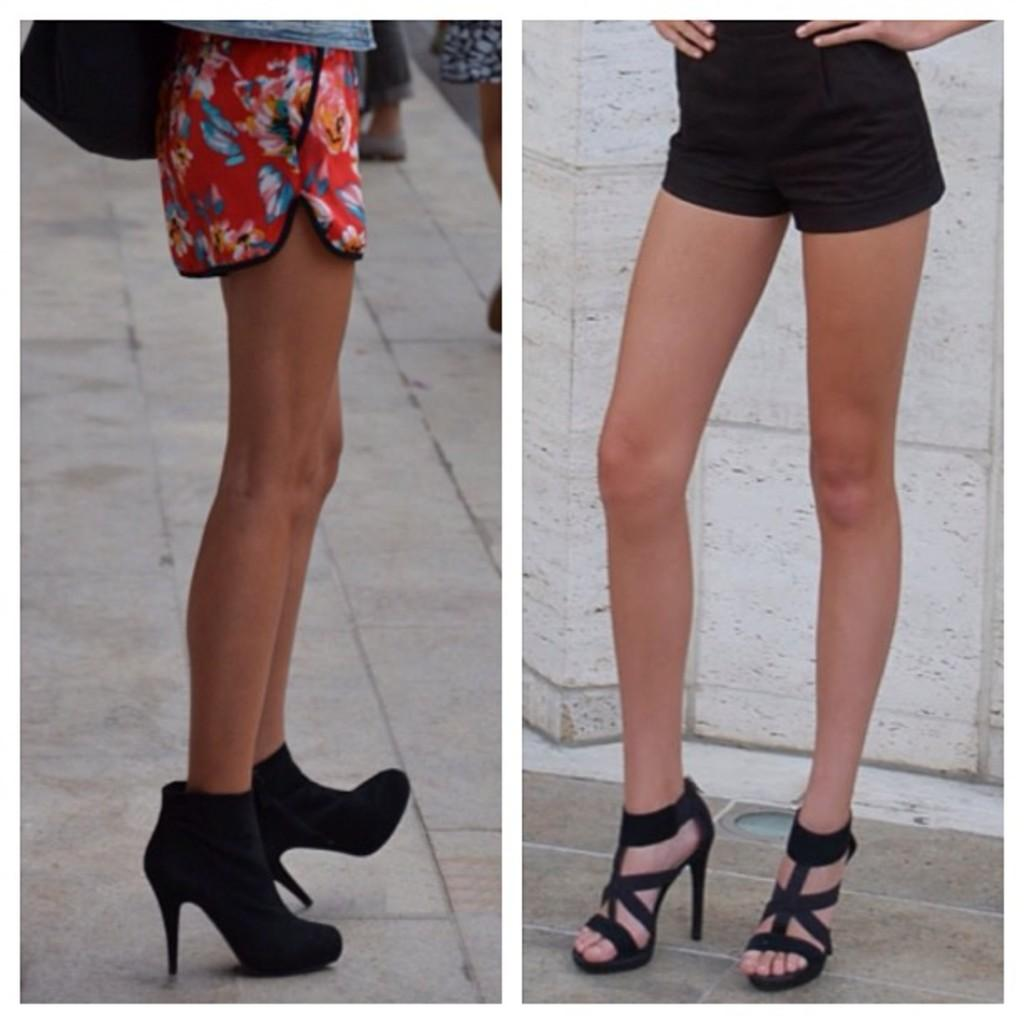What can be seen at the bottom of the image? There is a floor in the image. What is present on the floor? The legs of people wearing footwear can be seen on the floor. What is the background of the image? There is a wall in the image. What type of coal is being used by the machine in the image? There is no coal or machine present in the image. Are the people wearing stockings in the image? The provided facts do not mention stockings, so it cannot be determined from the image. 